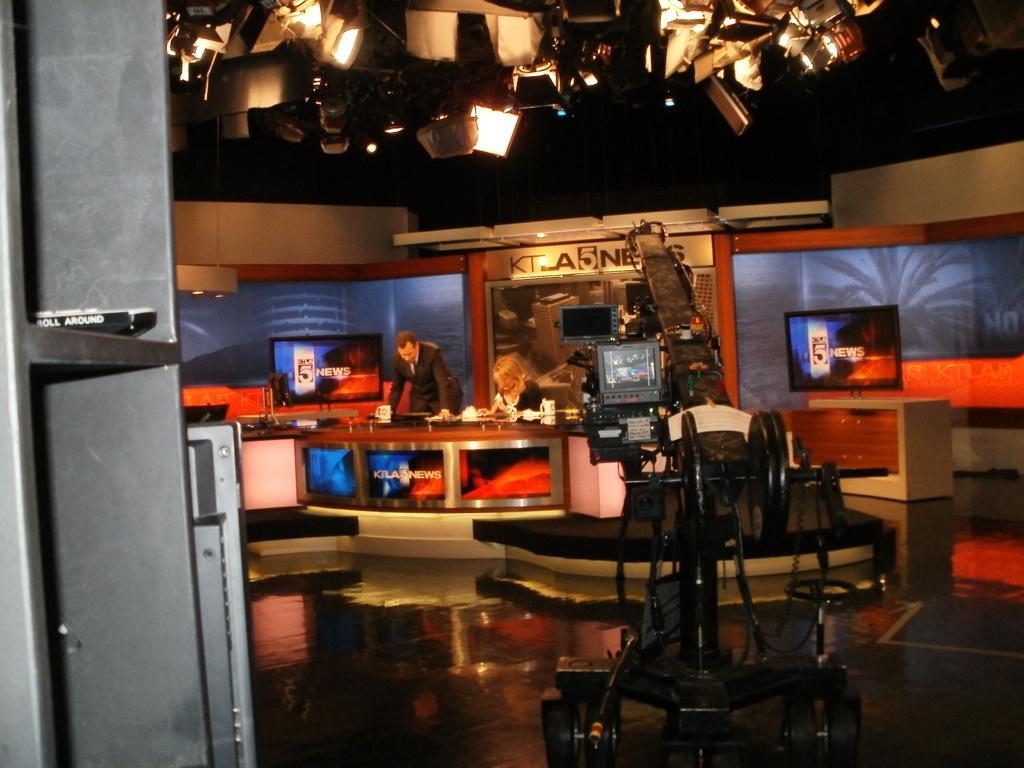Could you give a brief overview of what you see in this image? In this image we can see persons at the table. On the table we can see cups and papers. On the right side of the image television table and video camera. In the background we can see wall, picture, text. At the top of the image there are lights. 